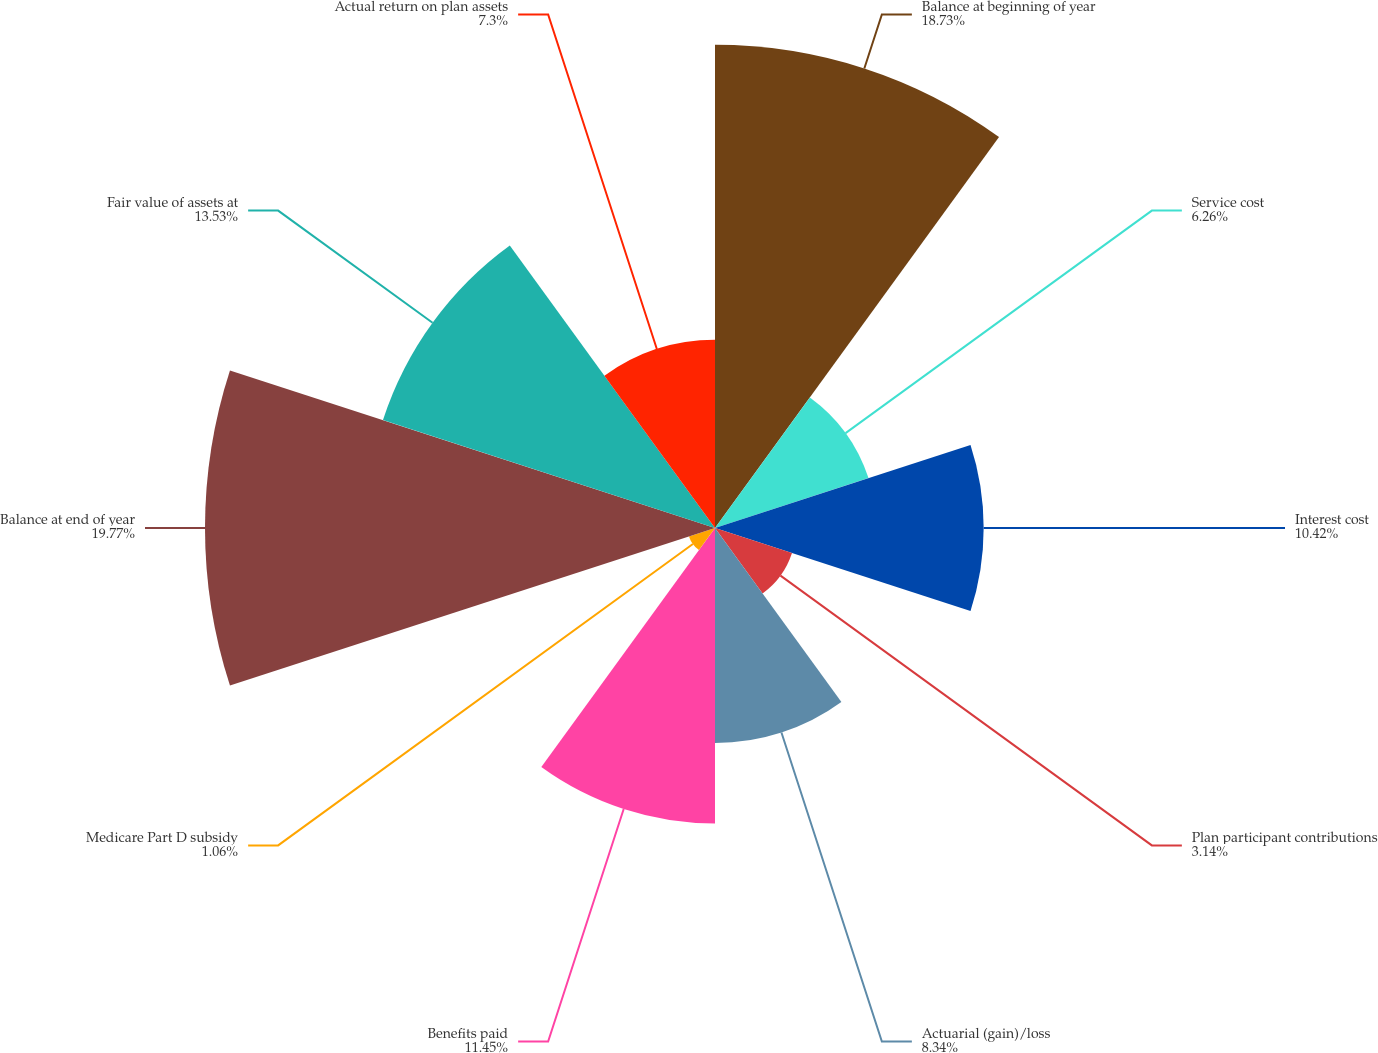Convert chart to OTSL. <chart><loc_0><loc_0><loc_500><loc_500><pie_chart><fcel>Balance at beginning of year<fcel>Service cost<fcel>Interest cost<fcel>Plan participant contributions<fcel>Actuarial (gain)/loss<fcel>Benefits paid<fcel>Medicare Part D subsidy<fcel>Balance at end of year<fcel>Fair value of assets at<fcel>Actual return on plan assets<nl><fcel>18.74%<fcel>6.26%<fcel>10.42%<fcel>3.14%<fcel>8.34%<fcel>11.46%<fcel>1.06%<fcel>19.78%<fcel>13.54%<fcel>7.3%<nl></chart> 